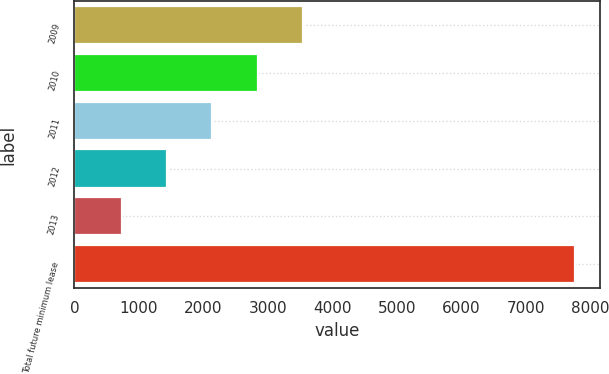<chart> <loc_0><loc_0><loc_500><loc_500><bar_chart><fcel>2009<fcel>2010<fcel>2011<fcel>2012<fcel>2013<fcel>Total future minimum lease<nl><fcel>3539.6<fcel>2837.2<fcel>2134.8<fcel>1432.4<fcel>730<fcel>7754<nl></chart> 